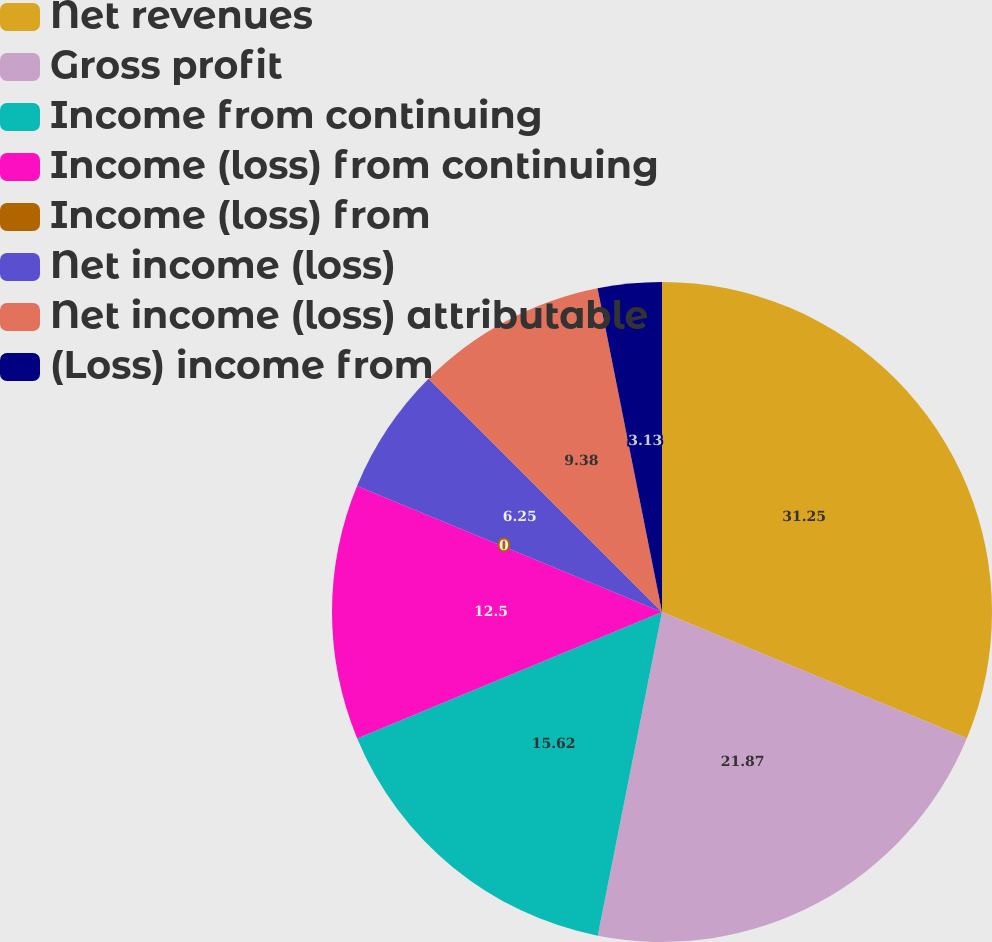Convert chart to OTSL. <chart><loc_0><loc_0><loc_500><loc_500><pie_chart><fcel>Net revenues<fcel>Gross profit<fcel>Income from continuing<fcel>Income (loss) from continuing<fcel>Income (loss) from<fcel>Net income (loss)<fcel>Net income (loss) attributable<fcel>(Loss) income from<nl><fcel>31.25%<fcel>21.87%<fcel>15.62%<fcel>12.5%<fcel>0.0%<fcel>6.25%<fcel>9.38%<fcel>3.13%<nl></chart> 